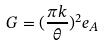Convert formula to latex. <formula><loc_0><loc_0><loc_500><loc_500>G = ( \frac { \pi k } { \theta } ) ^ { 2 } e _ { A }</formula> 